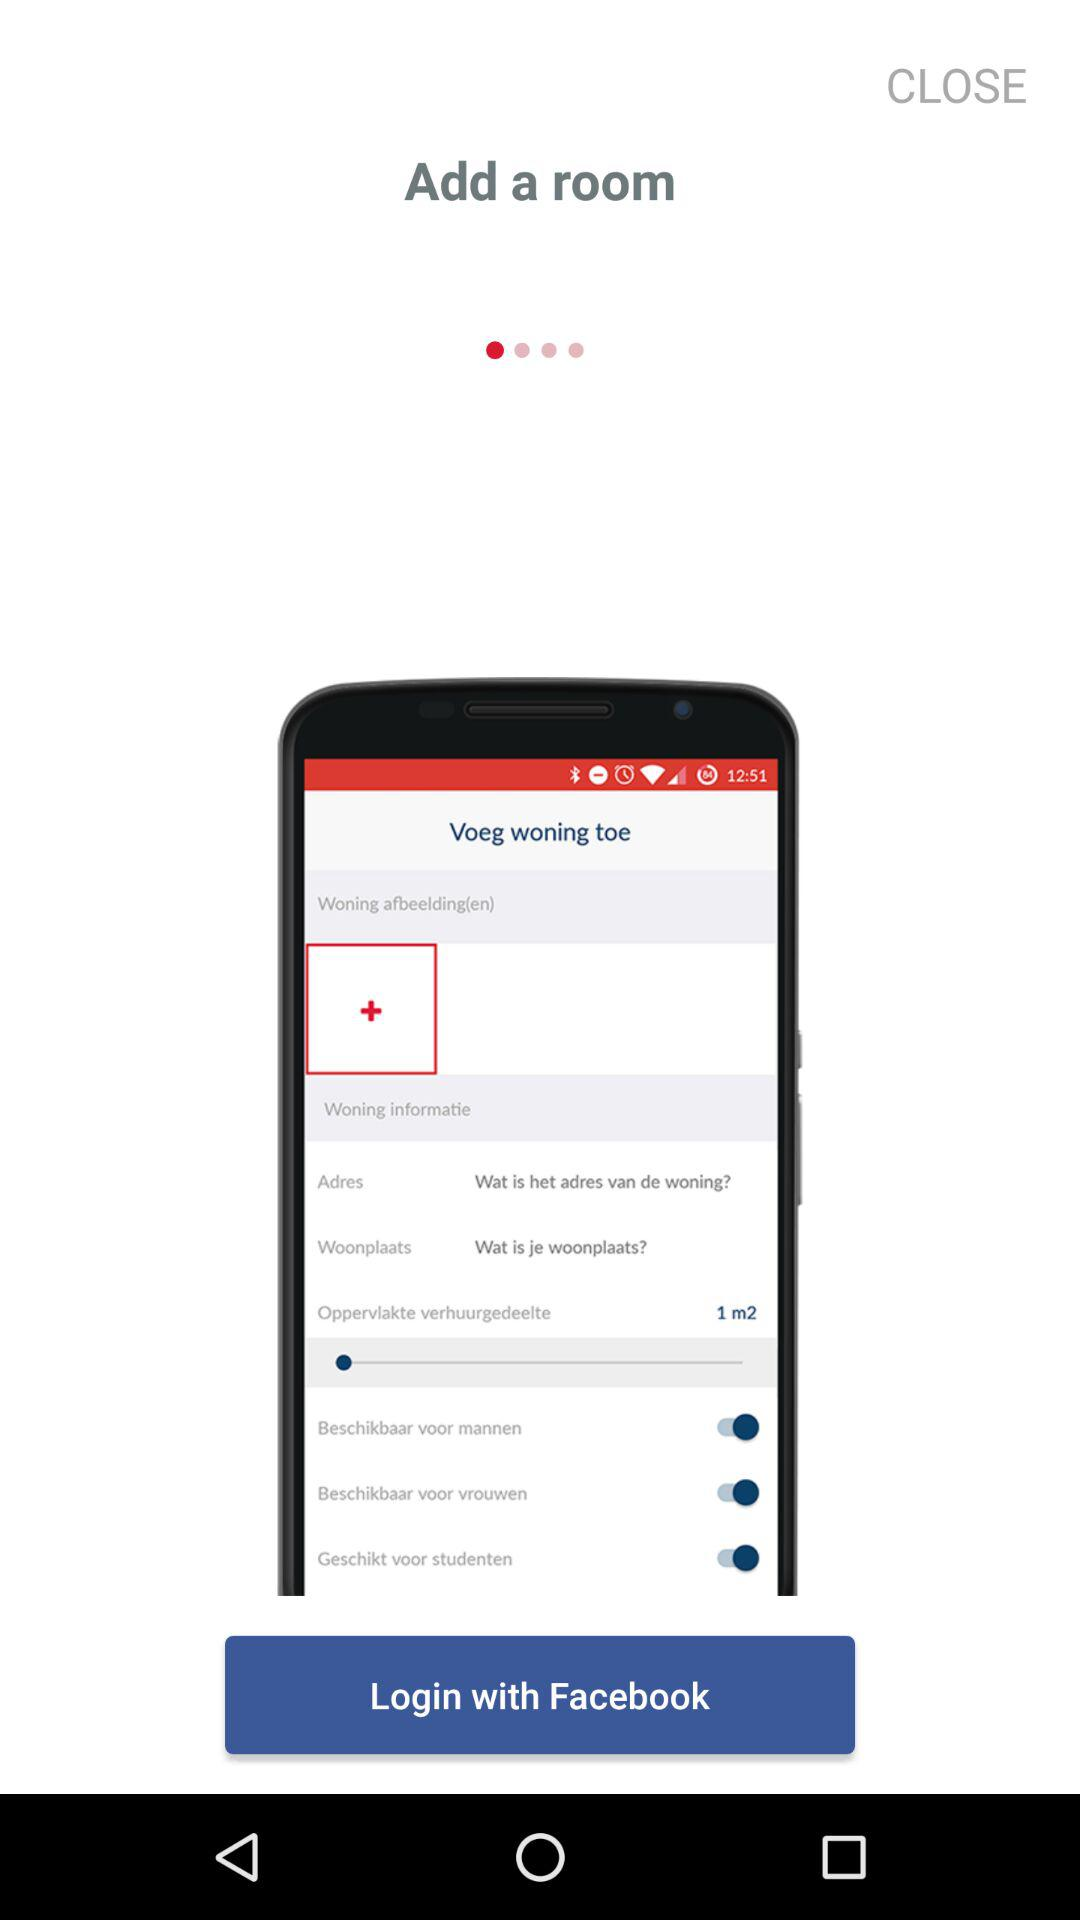Through what applications can we log in? You can log in through "Facebook". 